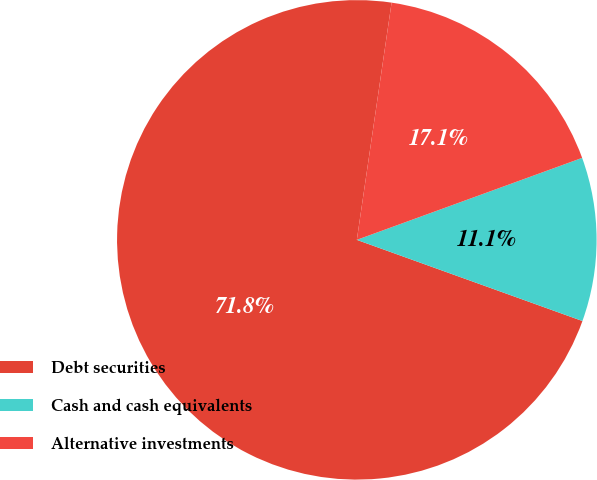Convert chart to OTSL. <chart><loc_0><loc_0><loc_500><loc_500><pie_chart><fcel>Debt securities<fcel>Cash and cash equivalents<fcel>Alternative investments<nl><fcel>71.82%<fcel>11.05%<fcel>17.13%<nl></chart> 